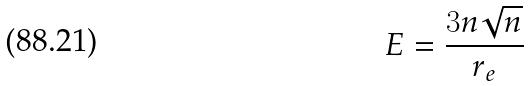<formula> <loc_0><loc_0><loc_500><loc_500>E = \frac { 3 n \sqrt { n } } { r _ { e } }</formula> 